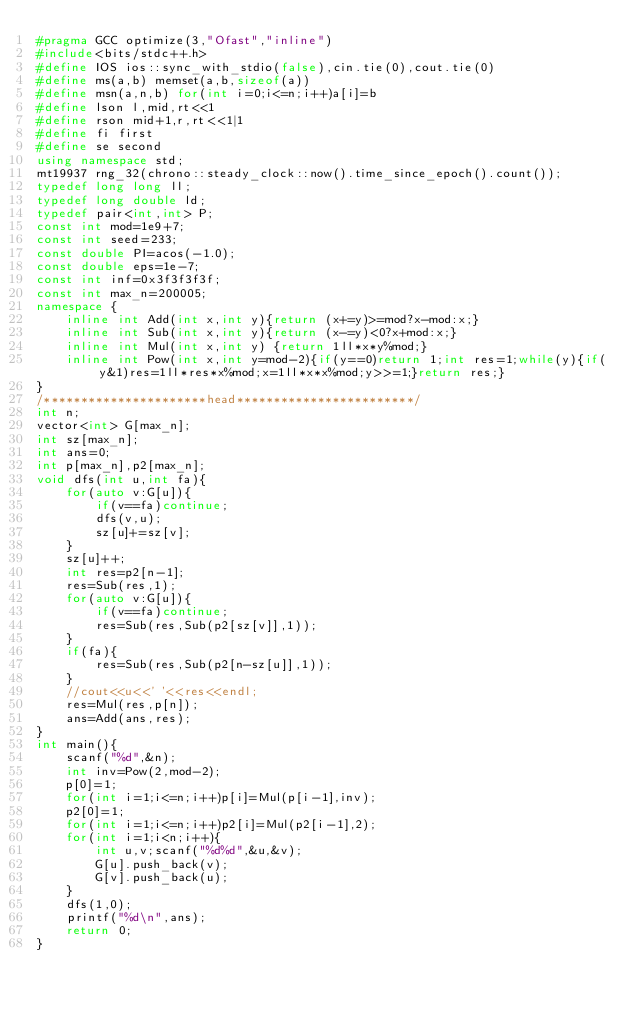Convert code to text. <code><loc_0><loc_0><loc_500><loc_500><_C++_>#pragma GCC optimize(3,"Ofast","inline")
#include<bits/stdc++.h>
#define IOS ios::sync_with_stdio(false),cin.tie(0),cout.tie(0)
#define ms(a,b) memset(a,b,sizeof(a))
#define msn(a,n,b) for(int i=0;i<=n;i++)a[i]=b
#define lson l,mid,rt<<1
#define rson mid+1,r,rt<<1|1
#define fi first
#define se second
using namespace std;
mt19937 rng_32(chrono::steady_clock::now().time_since_epoch().count());
typedef long long ll;
typedef long double ld;
typedef pair<int,int> P;
const int mod=1e9+7;
const int seed=233;
const double PI=acos(-1.0);
const double eps=1e-7;
const int inf=0x3f3f3f3f;
const int max_n=200005;
namespace {
    inline int Add(int x,int y){return (x+=y)>=mod?x-mod:x;}
    inline int Sub(int x,int y){return (x-=y)<0?x+mod:x;}
    inline int Mul(int x,int y) {return 1ll*x*y%mod;}
    inline int Pow(int x,int y=mod-2){if(y==0)return 1;int res=1;while(y){if(y&1)res=1ll*res*x%mod;x=1ll*x*x%mod;y>>=1;}return res;}
}
/**********************head************************/
int n;
vector<int> G[max_n];
int sz[max_n];
int ans=0;
int p[max_n],p2[max_n];
void dfs(int u,int fa){
    for(auto v:G[u]){
        if(v==fa)continue;
        dfs(v,u);
        sz[u]+=sz[v];
    }
    sz[u]++;
    int res=p2[n-1];
    res=Sub(res,1);
    for(auto v:G[u]){
        if(v==fa)continue;
        res=Sub(res,Sub(p2[sz[v]],1));
    }
    if(fa){
        res=Sub(res,Sub(p2[n-sz[u]],1));
    }
    //cout<<u<<' '<<res<<endl;
    res=Mul(res,p[n]);
    ans=Add(ans,res);
}
int main(){
    scanf("%d",&n);
    int inv=Pow(2,mod-2);
    p[0]=1;
    for(int i=1;i<=n;i++)p[i]=Mul(p[i-1],inv);
    p2[0]=1;
    for(int i=1;i<=n;i++)p2[i]=Mul(p2[i-1],2);
    for(int i=1;i<n;i++){
        int u,v;scanf("%d%d",&u,&v);
        G[u].push_back(v);
        G[v].push_back(u);
    }
    dfs(1,0);
    printf("%d\n",ans);
    return 0;
}</code> 